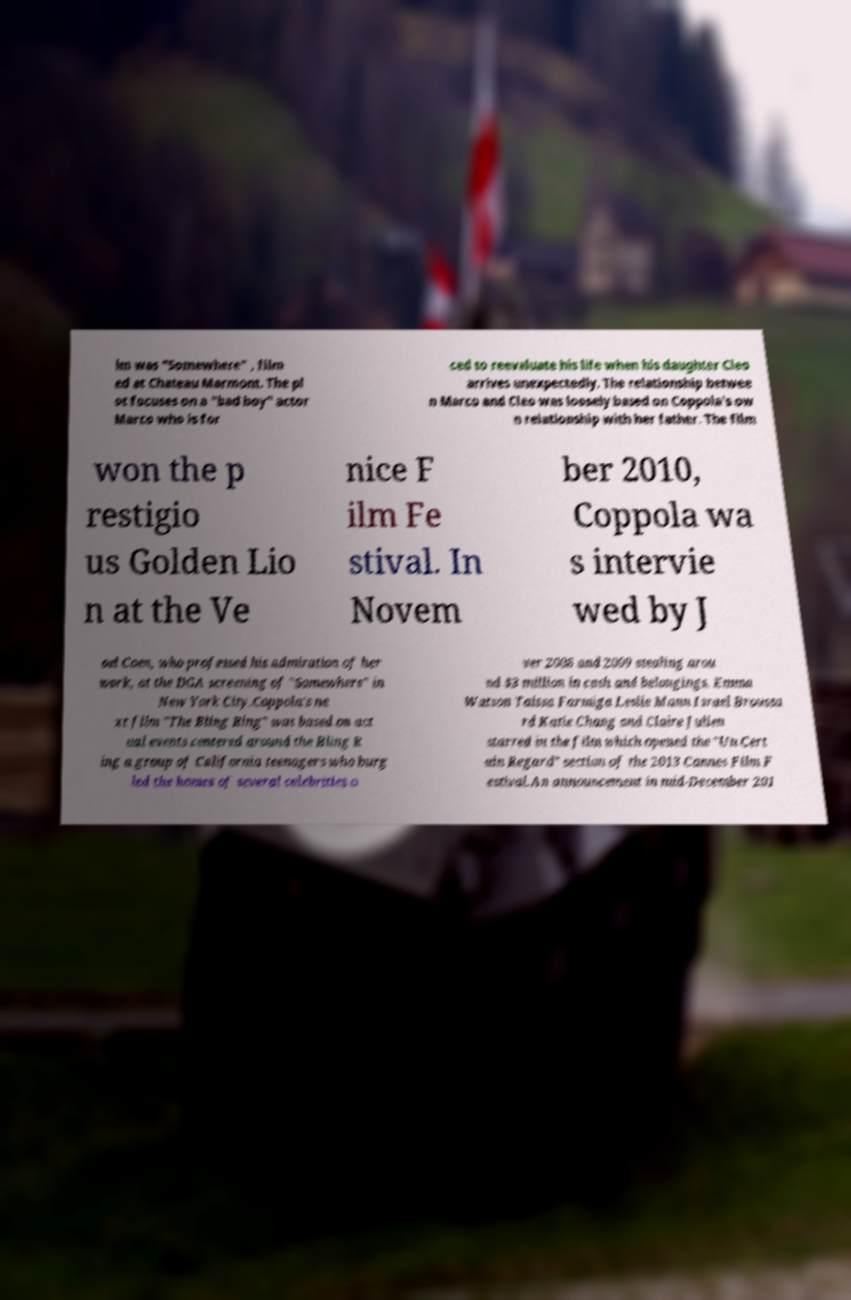Please identify and transcribe the text found in this image. lm was "Somewhere" , film ed at Chateau Marmont. The pl ot focuses on a "bad boy" actor Marco who is for ced to reevaluate his life when his daughter Cleo arrives unexpectedly. The relationship betwee n Marco and Cleo was loosely based on Coppola's ow n relationship with her father. The film won the p restigio us Golden Lio n at the Ve nice F ilm Fe stival. In Novem ber 2010, Coppola wa s intervie wed by J oel Coen, who professed his admiration of her work, at the DGA screening of "Somewhere" in New York City.Coppola's ne xt film "The Bling Ring" was based on act ual events centered around the Bling R ing a group of California teenagers who burg led the homes of several celebrities o ver 2008 and 2009 stealing arou nd $3 million in cash and belongings. Emma Watson Taissa Farmiga Leslie Mann Israel Broussa rd Katie Chang and Claire Julien starred in the film which opened the "Un Cert ain Regard" section of the 2013 Cannes Film F estival.An announcement in mid-December 201 